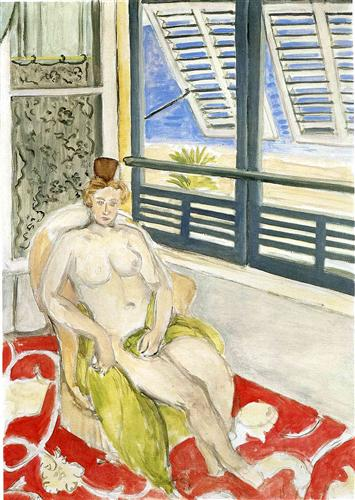How does the composition of the painting affect its overall feel? The composition of the painting plays a crucial role in crafting the ambiance of the scene. By positioning the woman centrally and surrounding her with the expanse of the room, the viewer's attention is drawn directly to her tranquil pose and expression. The open window and the view it offers pair with the woman's introspective state, symbolizing a portal to her inner thoughts. The simplicity of the furnishings and the strategic use of color harmonize to suggest a contemplative space, separate from the demands of the external world. 